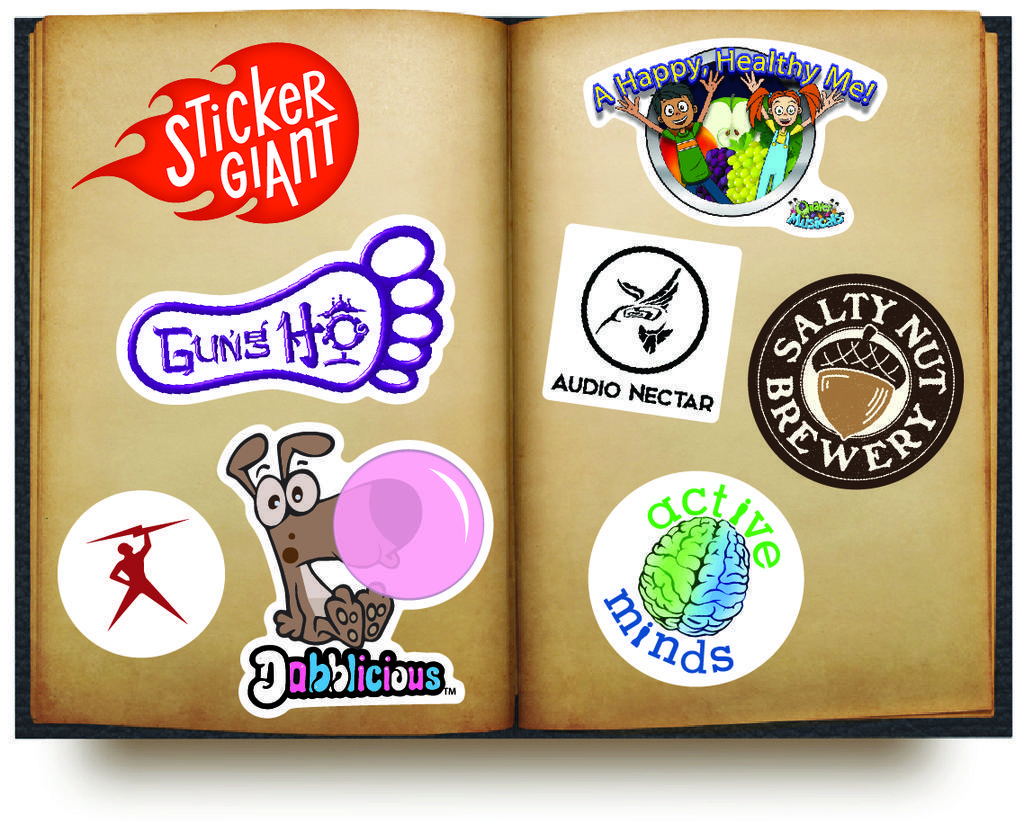How would you summarize this image in a sentence or two? In this image, we can see a book, in that book we can see some stickers pasted. 